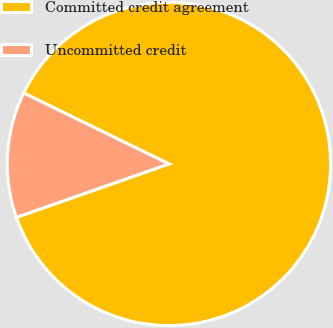Convert chart to OTSL. <chart><loc_0><loc_0><loc_500><loc_500><pie_chart><fcel>Committed credit agreement<fcel>Uncommitted credit<nl><fcel>87.41%<fcel>12.59%<nl></chart> 